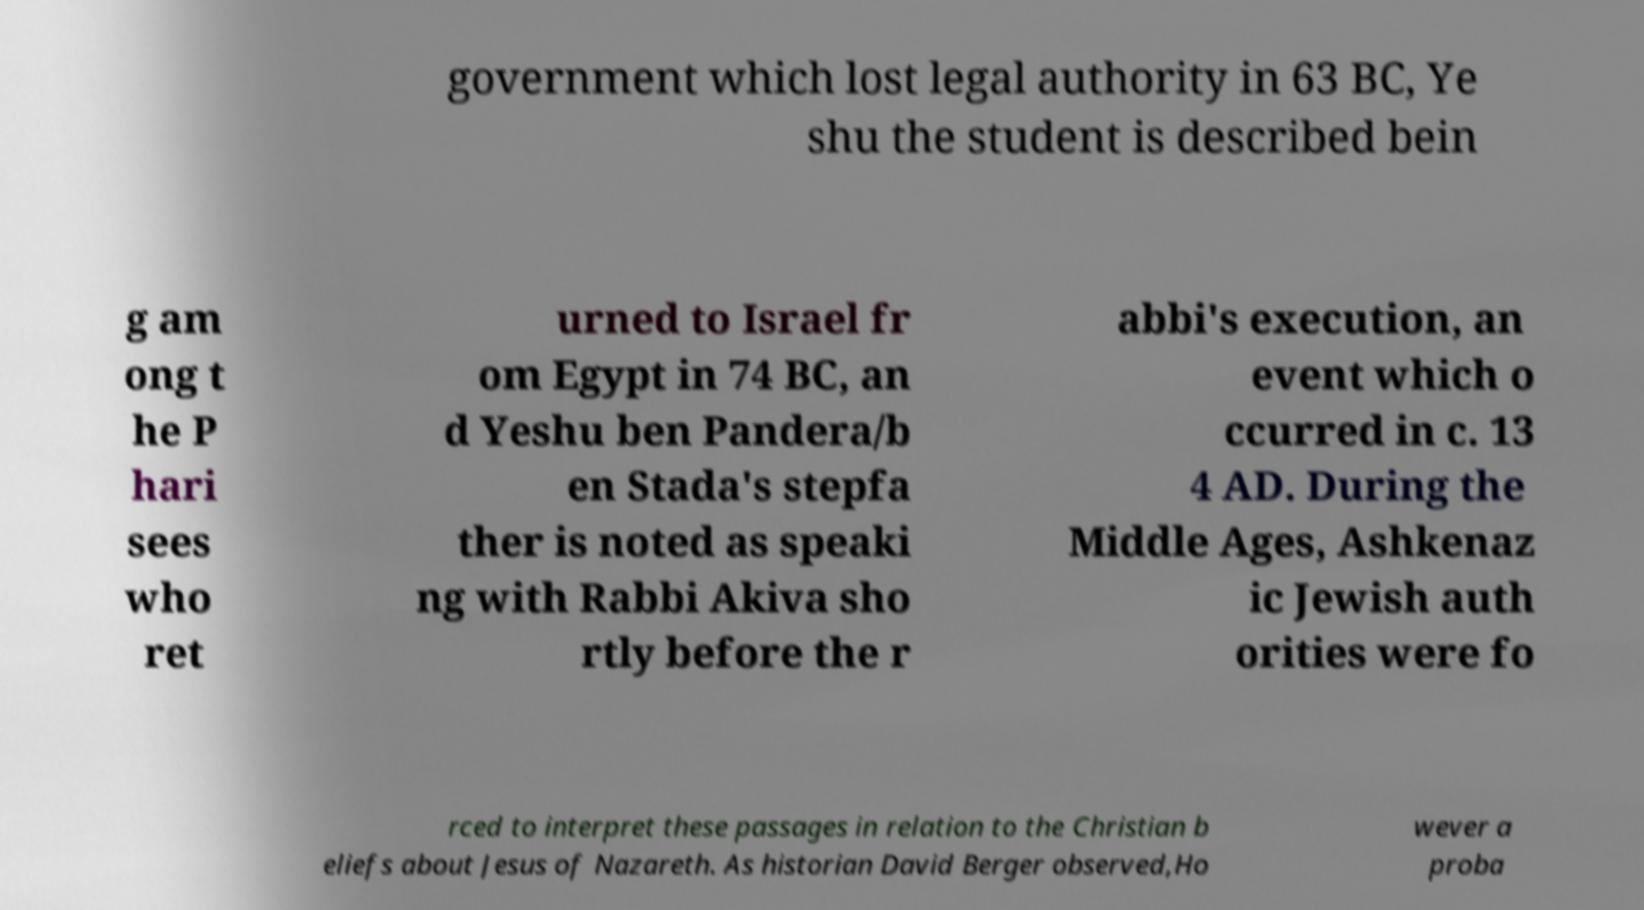I need the written content from this picture converted into text. Can you do that? government which lost legal authority in 63 BC, Ye shu the student is described bein g am ong t he P hari sees who ret urned to Israel fr om Egypt in 74 BC, an d Yeshu ben Pandera/b en Stada's stepfa ther is noted as speaki ng with Rabbi Akiva sho rtly before the r abbi's execution, an event which o ccurred in c. 13 4 AD. During the Middle Ages, Ashkenaz ic Jewish auth orities were fo rced to interpret these passages in relation to the Christian b eliefs about Jesus of Nazareth. As historian David Berger observed,Ho wever a proba 